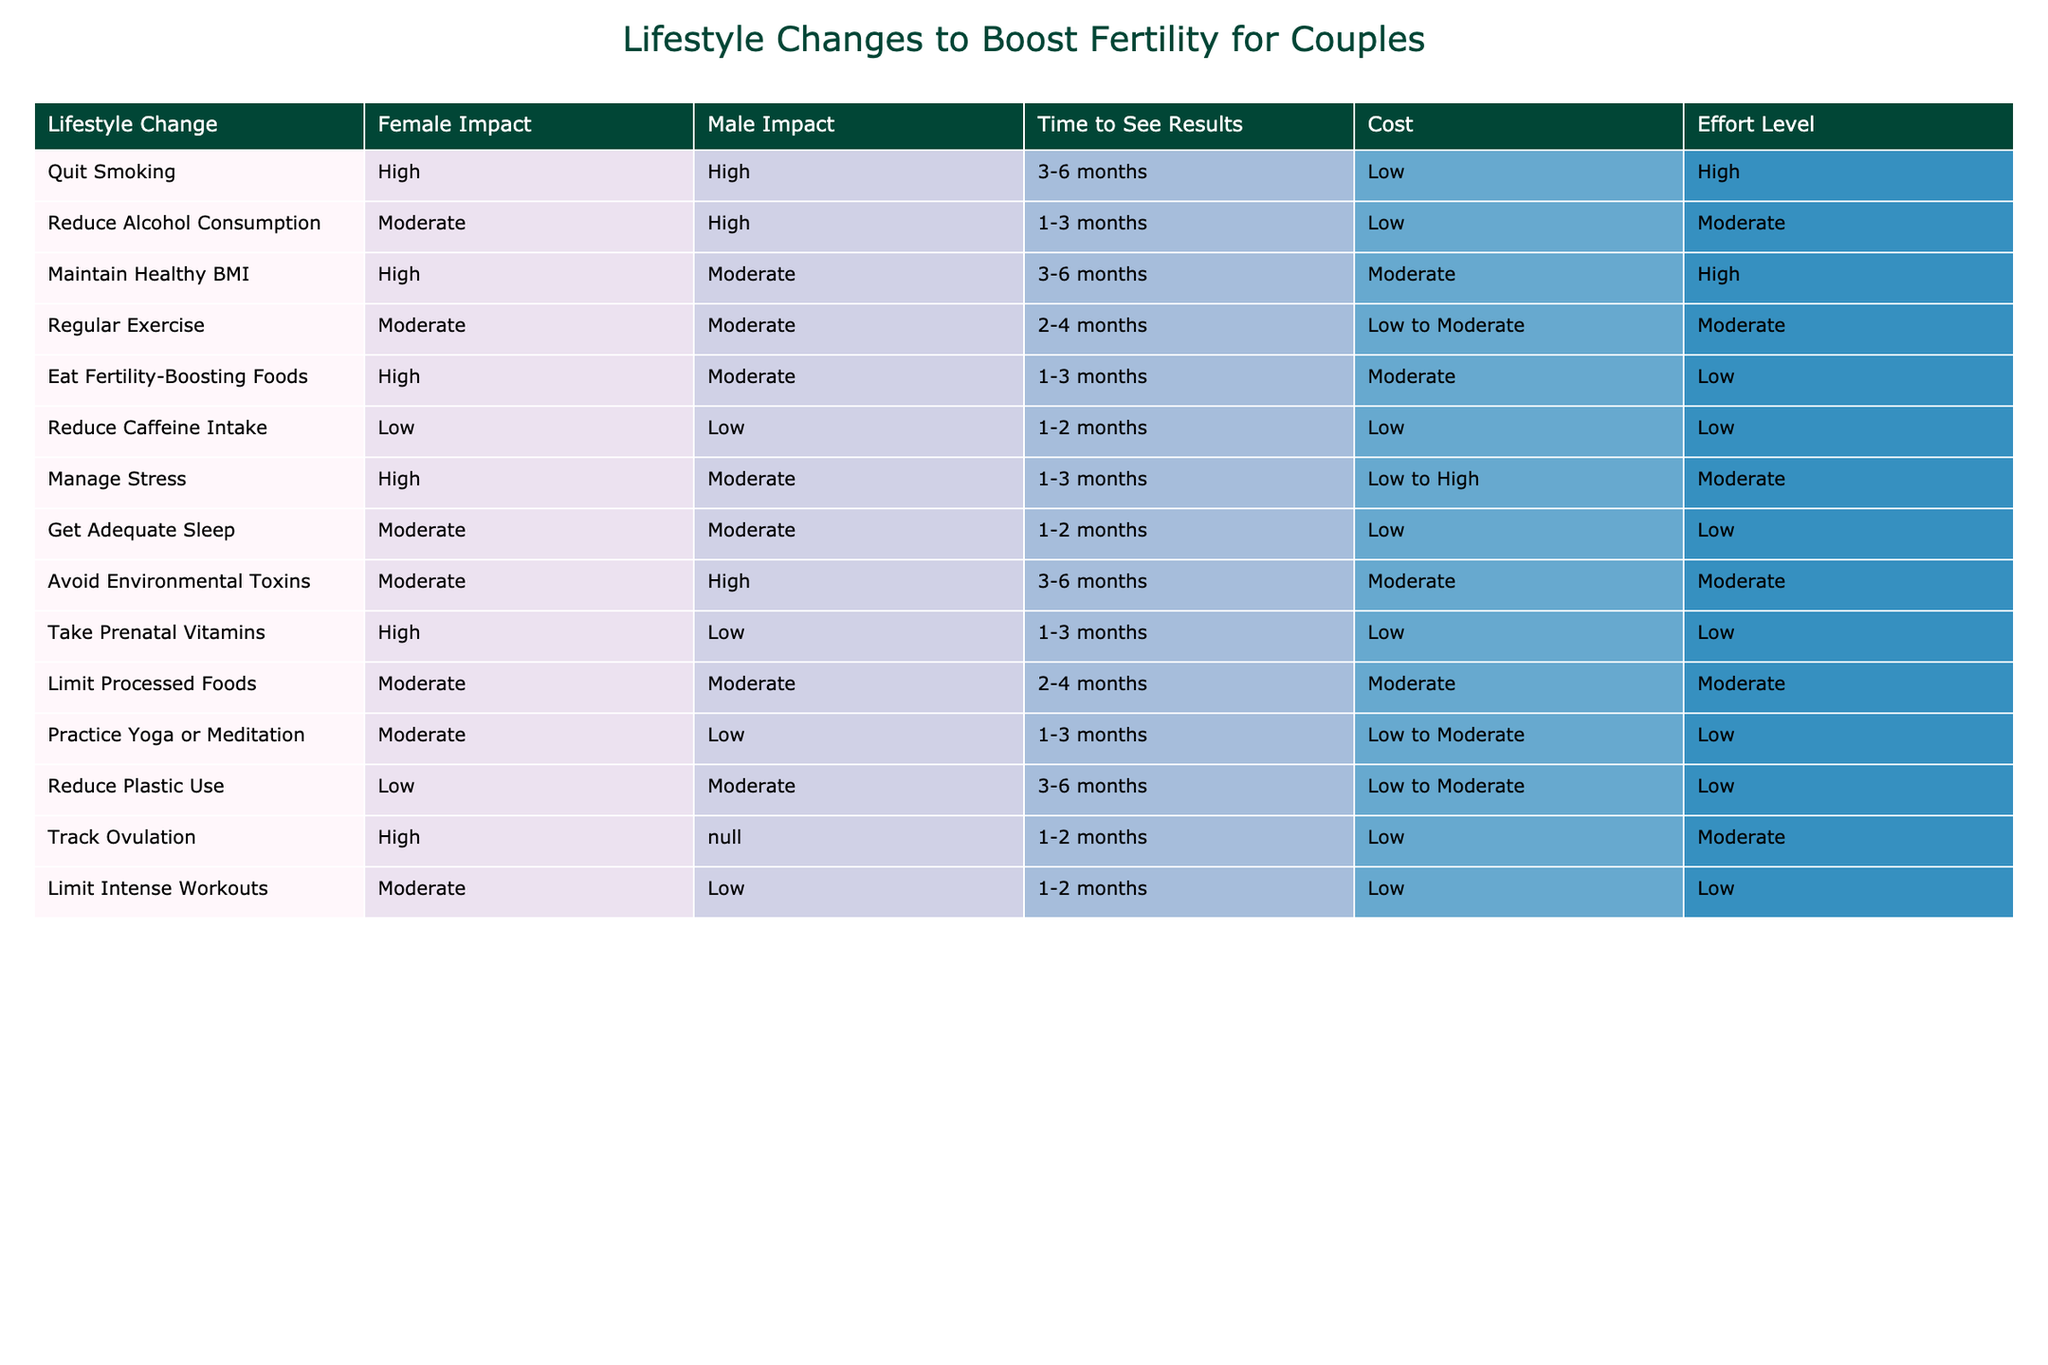What impact does quitting smoking have on female fertility? According to the table, quitting smoking has a "High" impact on female fertility, which is directly stated in the "Female Impact" column for that lifestyle change.
Answer: High How long does it take to see results from reducing alcohol consumption? The table indicates that reducing alcohol consumption takes "1-3 months" to see results as noted in the "Time to See Results" column.
Answer: 1-3 months Which lifestyle change has the highest impact on male fertility? By examining the "Male Impact" column, we see that quitting smoking and avoiding environmental toxins both have a "High" impact, making them the highest in that category.
Answer: Quit Smoking, Avoid Environmental Toxins What is the total number of lifestyle changes listed in the table? The table lists 12 different lifestyle changes. This is found by simply counting the rows in the table, excluding the header row.
Answer: 12 If a couple wants to see results in the shortest amount of time, which lifestyle changes should they consider? The quickest results are seen from reducing caffeine intake (1-2 months) and tracking ovulation (1-2 months). Both these actions fall within the shortest time frame, making them the best options for quick results.
Answer: Reduce Caffeine Intake, Track Ovulation Is practicing yoga or meditation more effective than getting adequate sleep for male fertility improvement? The "Male Impact" for practicing yoga or meditation is "Low" while getting adequate sleep has a "Moderate" impact. Therefore, getting adequate sleep is more effective than practicing yoga or meditation for male fertility improvement.
Answer: No What lifestyle change requires the highest effort level? Looking at the "Effort Level" column, quitting smoking requires a "High" level of effort, which is higher than any other lifestyle change listed in the table.
Answer: Quit Smoking Which lifestyle changes specifically have a moderate impact on both male and female fertility? In the table, the lifestyle changes that have a "Moderate" impact on both male and female fertility include: regular exercise, limit processed foods, manage stress, and avoid environmental toxins, as indicated in the respective columns.
Answer: Regular Exercise, Limit Processed Foods, Manage Stress, Avoid Environmental Toxins If a couple reduces their alcohol consumption, how does that impact both partners regarding fertility? According to the "Female Impact" column, reducing alcohol consumption has a "Moderate" impact on female fertility and a "High" impact on male fertility. This means that it benefits male fertility more significantly than female.
Answer: Moderate Female Impact, High Male Impact 